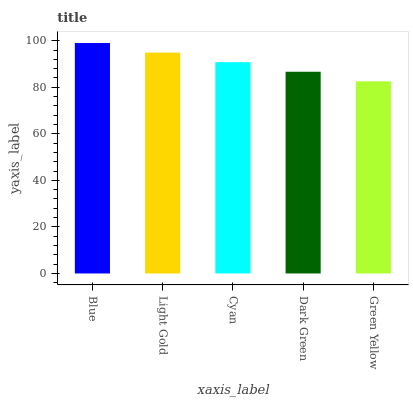Is Light Gold the minimum?
Answer yes or no. No. Is Light Gold the maximum?
Answer yes or no. No. Is Blue greater than Light Gold?
Answer yes or no. Yes. Is Light Gold less than Blue?
Answer yes or no. Yes. Is Light Gold greater than Blue?
Answer yes or no. No. Is Blue less than Light Gold?
Answer yes or no. No. Is Cyan the high median?
Answer yes or no. Yes. Is Cyan the low median?
Answer yes or no. Yes. Is Light Gold the high median?
Answer yes or no. No. Is Green Yellow the low median?
Answer yes or no. No. 